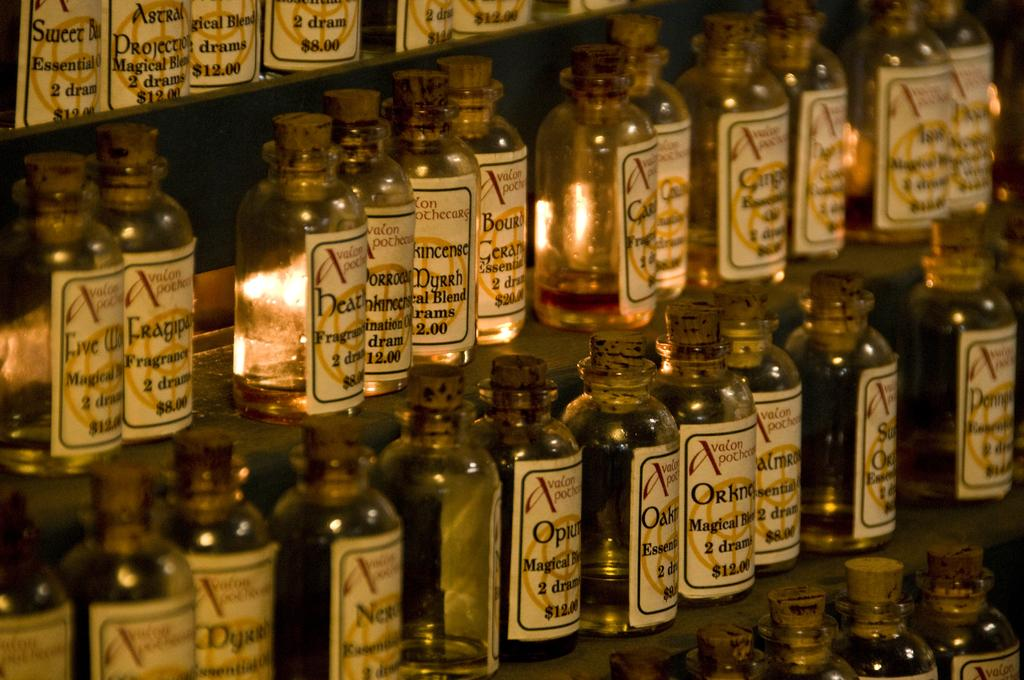<image>
Share a concise interpretation of the image provided. A large selection of products from Avalon Apothecary are displayed. 